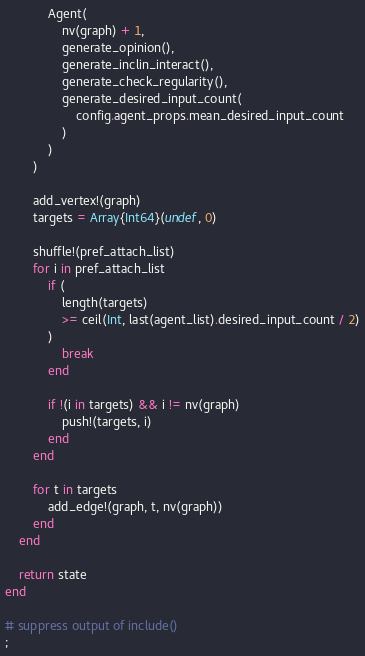<code> <loc_0><loc_0><loc_500><loc_500><_Julia_>            Agent(
                nv(graph) + 1,
                generate_opinion(),
                generate_inclin_interact(),
                generate_check_regularity(),
                generate_desired_input_count(
                    config.agent_props.mean_desired_input_count
                )
            )
        )

        add_vertex!(graph)
        targets = Array{Int64}(undef, 0)

        shuffle!(pref_attach_list)
        for i in pref_attach_list
            if (
                length(targets)
                >= ceil(Int, last(agent_list).desired_input_count / 2)
            )
                break
            end

            if !(i in targets) && i != nv(graph)
                push!(targets, i)
            end
        end

        for t in targets
            add_edge!(graph, t, nv(graph))
        end
    end

    return state
end

# suppress output of include()
;
</code> 